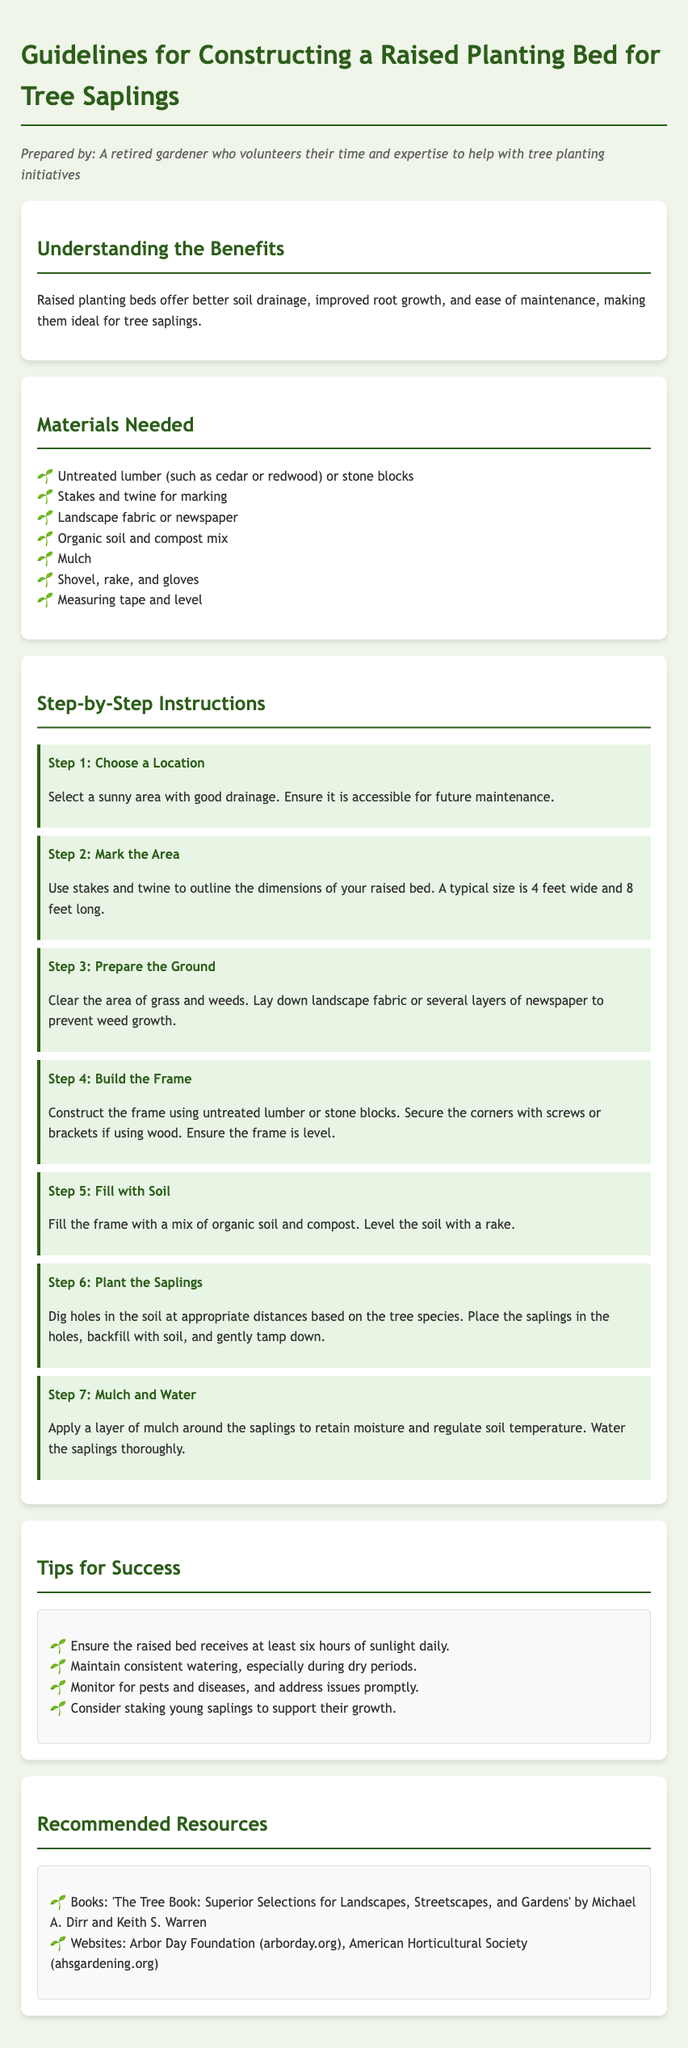what materials are needed for the raised bed? The materials listed for constructing the raised bed include untreated lumber or stone blocks, stakes and twine, landscape fabric or newspaper, organic soil and compost mix, mulch, shovel, rake, gloves, measuring tape, and level.
Answer: untreated lumber, stakes, landscape fabric, organic soil, mulch, shovel, rake, gloves, measuring tape, level what is the recommended size for a typical raised bed? The typical size for a raised bed mentioned in the document is 4 feet wide and 8 feet long.
Answer: 4 feet wide and 8 feet long how many steps are included in the instructions? The document outlines a total of 7 steps in the step-by-step instructions for constructing the raised planting bed.
Answer: 7 steps what should you apply around the saplings after planting? After planting, it is recommended to apply a layer of mulch around the saplings to help retain moisture.
Answer: mulch which tree planting benefit is mentioned in the document? The document highlights better soil drainage as a benefit of raised planting beds for tree saplings.
Answer: better soil drainage why should the raised bed receive sunlight? The document suggests ensuring the raised bed receives at least six hours of sunlight daily for the success of the saplings.
Answer: six hours of sunlight what is recommended to prevent weed growth? To prevent weed growth, the document advises laying down landscape fabric or several layers of newspaper.
Answer: landscape fabric or newspaper 